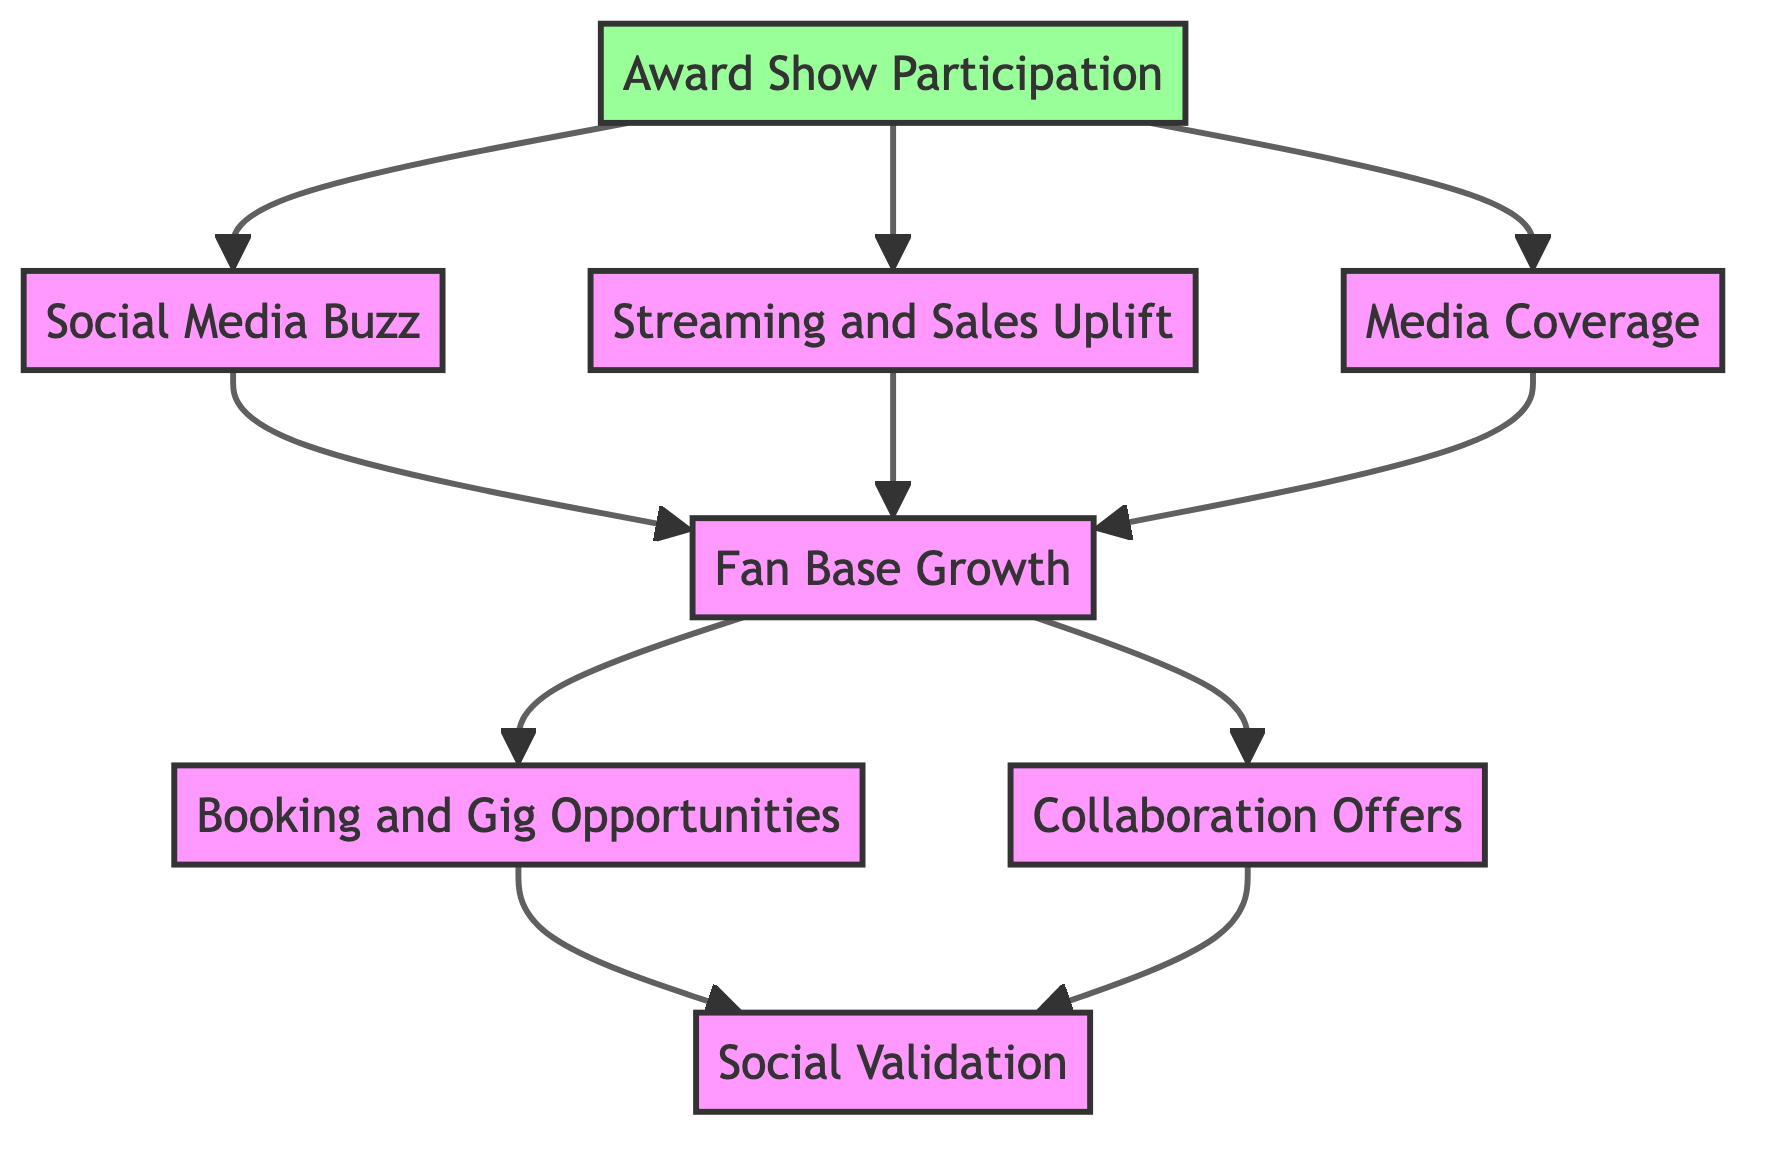What is the initial step in the diagram? The diagram indicates that the initial step involves "Award Show Participation," which serves as the starting point for evaluating the impact of music award shows.
Answer: Award Show Participation How many outcomes follow Social Media Buzz? From the diagram, "Social Media Buzz" leads to only one outcome, which is "Fan Base Growth," meaning it has a direct effect on this subsequent element.
Answer: 1 What precedes Fan Base Growth in the diagram? The diagram shows that "Social Media Buzz," "Streaming and Sales Uplift," and "Media Coverage" all lead into "Fan Base Growth," indicating these three elements contribute to fan engagement.
Answer: Social Media Buzz, Streaming and Sales Uplift, Media Coverage Which two nodes flow into Booking and Gig Opportunities? According to the flow chart, "Fan Base Growth" flows into "Booking and Gig Opportunities," indicating that an increase in fan engagement can create more booking inquiries.
Answer: Fan Base Growth What two elements lead to Social Validation? In the diagram, "Booking and Gig Opportunities" and "Collaboration Offers" both lead to "Social Validation," indicating that both aspects contribute to the artist's credibility in the music community.
Answer: Booking and Gig Opportunities, Collaboration Offers How many nodes are there in total? By counting all the unique elements present in the diagram: Award Show Participation, Social Media Buzz, Streaming and Sales Uplift, Media Coverage, Fan Base Growth, Booking and Gig Opportunities, Collaboration Offers, and Social Validation, we see that there are eight nodes total.
Answer: 8 What is the final outcome node in the diagram? The last node at the top of the flow chart is "Social Validation," which encapsulates the outcome of the evaluation process after all preceding elements are taken into account.
Answer: Social Validation What impacts Fan Base Growth? Three elements, "Social Media Buzz," "Streaming and Sales Uplift," and "Media Coverage," directly impact "Fan Base Growth," indicating multiple paths can lead to an increase in fan engagement.
Answer: Social Media Buzz, Streaming and Sales Uplift, Media Coverage 